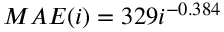Convert formula to latex. <formula><loc_0><loc_0><loc_500><loc_500>M A E ( i ) = 3 2 9 i ^ { - 0 . 3 8 4 }</formula> 